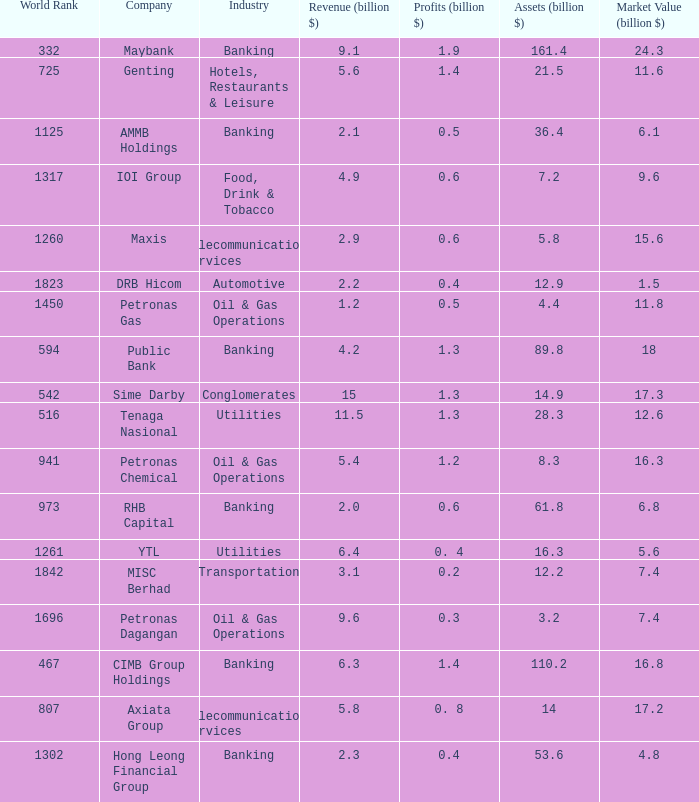Name the industry for revenue being 2.1 Banking. 